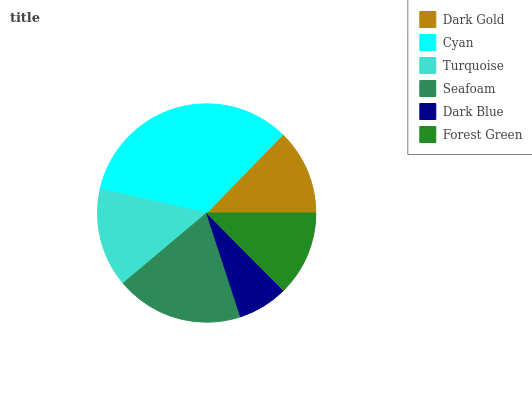Is Dark Blue the minimum?
Answer yes or no. Yes. Is Cyan the maximum?
Answer yes or no. Yes. Is Turquoise the minimum?
Answer yes or no. No. Is Turquoise the maximum?
Answer yes or no. No. Is Cyan greater than Turquoise?
Answer yes or no. Yes. Is Turquoise less than Cyan?
Answer yes or no. Yes. Is Turquoise greater than Cyan?
Answer yes or no. No. Is Cyan less than Turquoise?
Answer yes or no. No. Is Turquoise the high median?
Answer yes or no. Yes. Is Dark Gold the low median?
Answer yes or no. Yes. Is Dark Gold the high median?
Answer yes or no. No. Is Forest Green the low median?
Answer yes or no. No. 